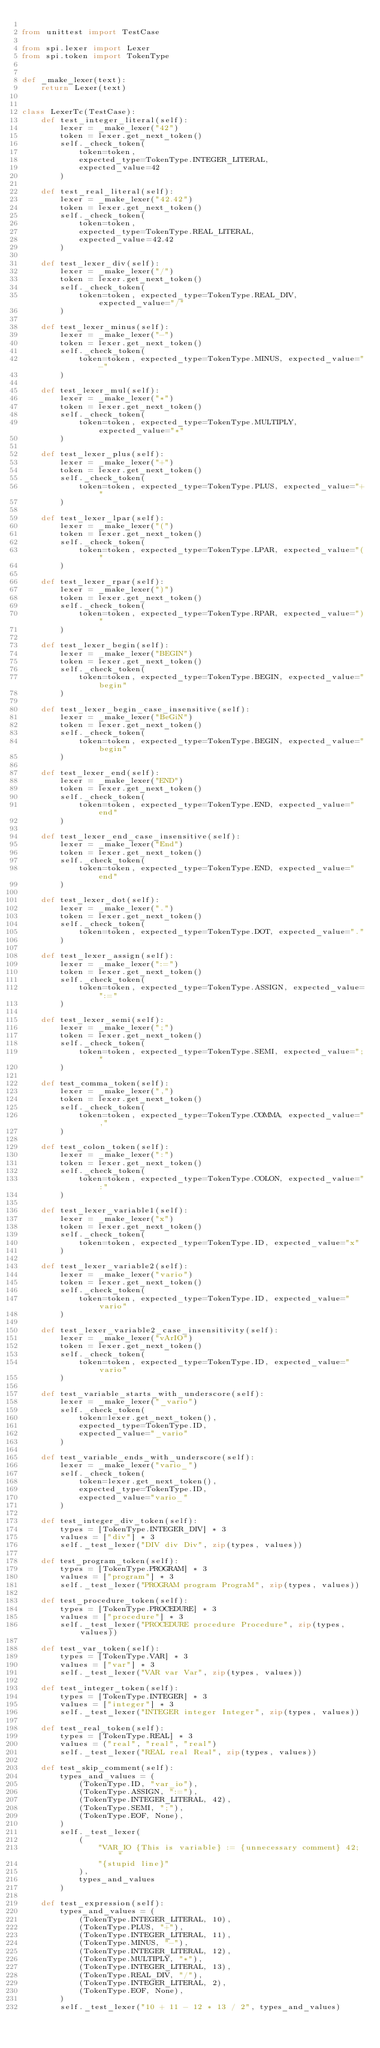Convert code to text. <code><loc_0><loc_0><loc_500><loc_500><_Python_>
from unittest import TestCase

from spi.lexer import Lexer
from spi.token import TokenType


def _make_lexer(text):
    return Lexer(text)


class LexerTc(TestCase):
    def test_integer_literal(self):
        lexer = _make_lexer("42")
        token = lexer.get_next_token()
        self._check_token(
            token=token,
            expected_type=TokenType.INTEGER_LITERAL,
            expected_value=42
        )

    def test_real_literal(self):
        lexer = _make_lexer("42.42")
        token = lexer.get_next_token()
        self._check_token(
            token=token,
            expected_type=TokenType.REAL_LITERAL,
            expected_value=42.42
        )

    def test_lexer_div(self):
        lexer = _make_lexer("/")
        token = lexer.get_next_token()
        self._check_token(
            token=token, expected_type=TokenType.REAL_DIV, expected_value="/"
        )

    def test_lexer_minus(self):
        lexer = _make_lexer("-")
        token = lexer.get_next_token()
        self._check_token(
            token=token, expected_type=TokenType.MINUS, expected_value="-"
        )

    def test_lexer_mul(self):
        lexer = _make_lexer("*")
        token = lexer.get_next_token()
        self._check_token(
            token=token, expected_type=TokenType.MULTIPLY, expected_value="*"
        )

    def test_lexer_plus(self):
        lexer = _make_lexer("+")
        token = lexer.get_next_token()
        self._check_token(
            token=token, expected_type=TokenType.PLUS, expected_value="+"
        )

    def test_lexer_lpar(self):
        lexer = _make_lexer("(")
        token = lexer.get_next_token()
        self._check_token(
            token=token, expected_type=TokenType.LPAR, expected_value="("
        )

    def test_lexer_rpar(self):
        lexer = _make_lexer(")")
        token = lexer.get_next_token()
        self._check_token(
            token=token, expected_type=TokenType.RPAR, expected_value=")"
        )

    def test_lexer_begin(self):
        lexer = _make_lexer("BEGIN")
        token = lexer.get_next_token()
        self._check_token(
            token=token, expected_type=TokenType.BEGIN, expected_value="begin"
        )

    def test_lexer_begin_case_insensitive(self):
        lexer = _make_lexer("BeGiN")
        token = lexer.get_next_token()
        self._check_token(
            token=token, expected_type=TokenType.BEGIN, expected_value="begin"
        )

    def test_lexer_end(self):
        lexer = _make_lexer("END")
        token = lexer.get_next_token()
        self._check_token(
            token=token, expected_type=TokenType.END, expected_value="end"
        )

    def test_lexer_end_case_insensitive(self):
        lexer = _make_lexer("End")
        token = lexer.get_next_token()
        self._check_token(
            token=token, expected_type=TokenType.END, expected_value="end"
        )

    def test_lexer_dot(self):
        lexer = _make_lexer(".")
        token = lexer.get_next_token()
        self._check_token(
            token=token, expected_type=TokenType.DOT, expected_value="."
        )

    def test_lexer_assign(self):
        lexer = _make_lexer(":=")
        token = lexer.get_next_token()
        self._check_token(
            token=token, expected_type=TokenType.ASSIGN, expected_value=":="
        )

    def test_lexer_semi(self):
        lexer = _make_lexer(";")
        token = lexer.get_next_token()
        self._check_token(
            token=token, expected_type=TokenType.SEMI, expected_value=";"
        )

    def test_comma_token(self):
        lexer = _make_lexer(",")
        token = lexer.get_next_token()
        self._check_token(
            token=token, expected_type=TokenType.COMMA, expected_value=","
        )

    def test_colon_token(self):
        lexer = _make_lexer(":")
        token = lexer.get_next_token()
        self._check_token(
            token=token, expected_type=TokenType.COLON, expected_value=":"
        )

    def test_lexer_variable1(self):
        lexer = _make_lexer("x")
        token = lexer.get_next_token()
        self._check_token(
            token=token, expected_type=TokenType.ID, expected_value="x"
        )

    def test_lexer_variable2(self):
        lexer = _make_lexer("vario")
        token = lexer.get_next_token()
        self._check_token(
            token=token, expected_type=TokenType.ID, expected_value="vario"
        )

    def test_lexer_variable2_case_insensitivity(self):
        lexer = _make_lexer("vArIO")
        token = lexer.get_next_token()
        self._check_token(
            token=token, expected_type=TokenType.ID, expected_value="vario"
        )

    def test_variable_starts_with_underscore(self):
        lexer = _make_lexer("_vario")
        self._check_token(
            token=lexer.get_next_token(),
            expected_type=TokenType.ID,
            expected_value="_vario"
        )

    def test_variable_ends_with_underscore(self):
        lexer = _make_lexer("vario_")
        self._check_token(
            token=lexer.get_next_token(),
            expected_type=TokenType.ID,
            expected_value="vario_"
        )

    def test_integer_div_token(self):
        types = [TokenType.INTEGER_DIV] * 3
        values = ["div"] * 3
        self._test_lexer("DIV div Div", zip(types, values))

    def test_program_token(self):
        types = [TokenType.PROGRAM] * 3
        values = ["program"] * 3
        self._test_lexer("PROGRAM program PrograM", zip(types, values))

    def test_procedure_token(self):
        types = [TokenType.PROCEDURE] * 3
        values = ["procedure"] * 3
        self._test_lexer("PROCEDURE procedure Procedure", zip(types, values))

    def test_var_token(self):
        types = [TokenType.VAR] * 3
        values = ["var"] * 3
        self._test_lexer("VAR var Var", zip(types, values))

    def test_integer_token(self):
        types = [TokenType.INTEGER] * 3
        values = ["integer"] * 3
        self._test_lexer("INTEGER integer Integer", zip(types, values))

    def test_real_token(self):
        types = [TokenType.REAL] * 3
        values = ("real", "real", "real")
        self._test_lexer("REAL real Real", zip(types, values))

    def test_skip_comment(self):
        types_and_values = (
            (TokenType.ID, "var_io"),
            (TokenType.ASSIGN, ":="),
            (TokenType.INTEGER_LITERAL, 42),
            (TokenType.SEMI, ";"),
            (TokenType.EOF, None),
        )
        self._test_lexer(
            (
                "VAR_IO {This is variable} := {unnecessary comment} 42; "
                "{stupid line}"
            ),
            types_and_values
        )

    def test_expression(self):
        types_and_values = (
            (TokenType.INTEGER_LITERAL, 10),
            (TokenType.PLUS, "+"),
            (TokenType.INTEGER_LITERAL, 11),
            (TokenType.MINUS, "-"),
            (TokenType.INTEGER_LITERAL, 12),
            (TokenType.MULTIPLY, "*"),
            (TokenType.INTEGER_LITERAL, 13),
            (TokenType.REAL_DIV, "/"),
            (TokenType.INTEGER_LITERAL, 2),
            (TokenType.EOF, None),
        )
        self._test_lexer("10 + 11 - 12 * 13 / 2", types_and_values)
</code> 